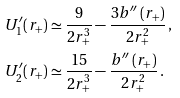Convert formula to latex. <formula><loc_0><loc_0><loc_500><loc_500>U _ { 1 } ^ { \prime } ( r _ { + } ) & \simeq \frac { 9 } { 2 r _ { + } ^ { 3 } } - \frac { 3 b ^ { \prime \prime } \left ( r _ { + } \right ) } { 2 r _ { + } ^ { 2 } } \, , \\ U _ { 2 } ^ { \prime } ( r _ { + } ) & \simeq \frac { 1 5 } { 2 r _ { + } ^ { 3 } } - \frac { b ^ { \prime \prime } \left ( r _ { + } \right ) } { 2 r _ { + } ^ { 2 } } \, .</formula> 